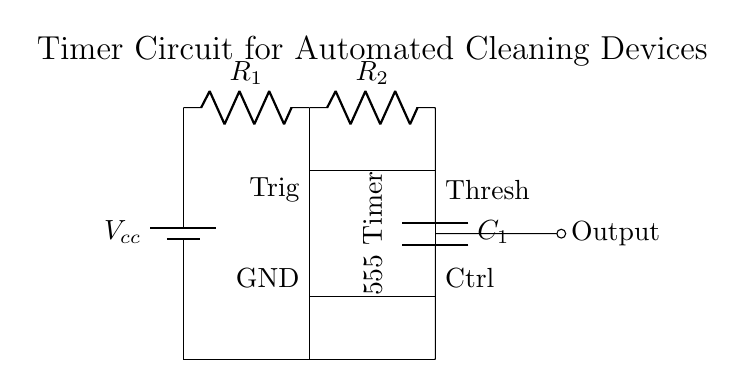What is the main component of this circuit? The main component is the 555 Timer, which is a widely used integrated circuit for timer, delay, pulse generation, and oscillator applications.
Answer: 555 Timer What are the values of the resistors in this circuit? The circuit includes two resistors labeled as R1 and R2, but no specific values are given. The types and connections would determine the resistor values in practical applications.
Answer: R1 and R2 What does the output connect to? The output connects to a terminal indicated as "Output," which typically drives another component, such as a motor or a relay, in the cleaning device.
Answer: Output What is the primary purpose of this timer circuit? The primary purpose of this timer circuit is to control the timing of automated cleaning devices, providing a delay before starting the operation or controlling how long the device runs.
Answer: Timing control Which component is responsible for creating a delay in this circuit? The capacitor C1 in conjunction with resistors R1 and R2 is responsible for determining the time delay in the circuit, as it charges and discharges, controlling how long the output remains active.
Answer: Capacitor C1 How is the control voltage adjusted in this circuit? The control voltage is adjusted through the control pin labeled "Ctrl," allowing for manipulation of the timer operation by overriding the timing set by R1 and R2.
Answer: Control pin 